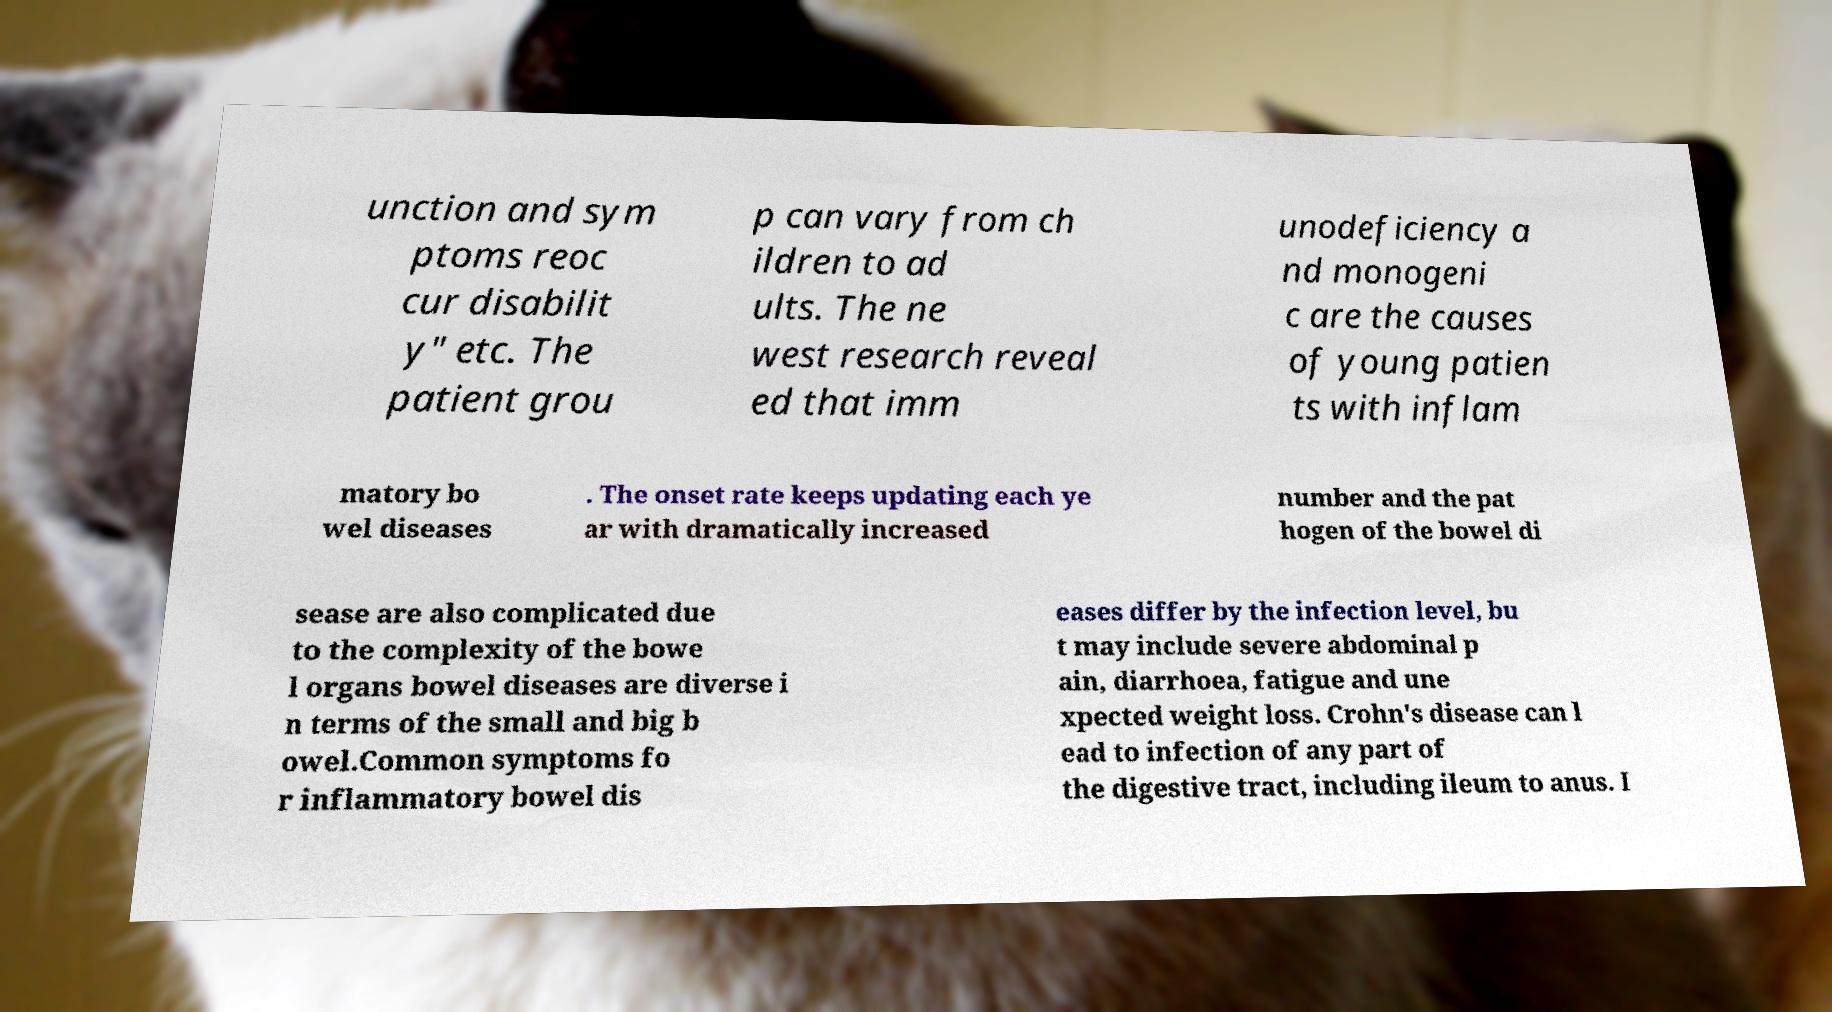Could you extract and type out the text from this image? unction and sym ptoms reoc cur disabilit y" etc. The patient grou p can vary from ch ildren to ad ults. The ne west research reveal ed that imm unodeficiency a nd monogeni c are the causes of young patien ts with inflam matory bo wel diseases . The onset rate keeps updating each ye ar with dramatically increased number and the pat hogen of the bowel di sease are also complicated due to the complexity of the bowe l organs bowel diseases are diverse i n terms of the small and big b owel.Common symptoms fo r inflammatory bowel dis eases differ by the infection level, bu t may include severe abdominal p ain, diarrhoea, fatigue and une xpected weight loss. Crohn's disease can l ead to infection of any part of the digestive tract, including ileum to anus. I 